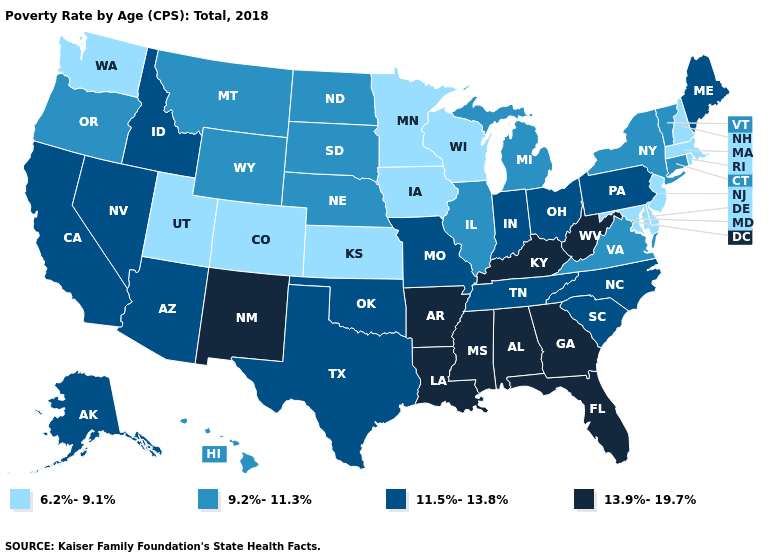Among the states that border Massachusetts , does Rhode Island have the lowest value?
Answer briefly. Yes. Does Missouri have the highest value in the MidWest?
Write a very short answer. Yes. How many symbols are there in the legend?
Quick response, please. 4. What is the value of West Virginia?
Be succinct. 13.9%-19.7%. What is the value of Wisconsin?
Short answer required. 6.2%-9.1%. Name the states that have a value in the range 13.9%-19.7%?
Be succinct. Alabama, Arkansas, Florida, Georgia, Kentucky, Louisiana, Mississippi, New Mexico, West Virginia. What is the lowest value in the MidWest?
Quick response, please. 6.2%-9.1%. Does West Virginia have the highest value in the South?
Write a very short answer. Yes. How many symbols are there in the legend?
Concise answer only. 4. Does South Carolina have a lower value than North Dakota?
Quick response, please. No. Among the states that border Indiana , does Michigan have the highest value?
Answer briefly. No. Which states have the lowest value in the South?
Concise answer only. Delaware, Maryland. Name the states that have a value in the range 9.2%-11.3%?
Give a very brief answer. Connecticut, Hawaii, Illinois, Michigan, Montana, Nebraska, New York, North Dakota, Oregon, South Dakota, Vermont, Virginia, Wyoming. Which states have the lowest value in the USA?
Concise answer only. Colorado, Delaware, Iowa, Kansas, Maryland, Massachusetts, Minnesota, New Hampshire, New Jersey, Rhode Island, Utah, Washington, Wisconsin. Does California have the same value as Florida?
Give a very brief answer. No. 